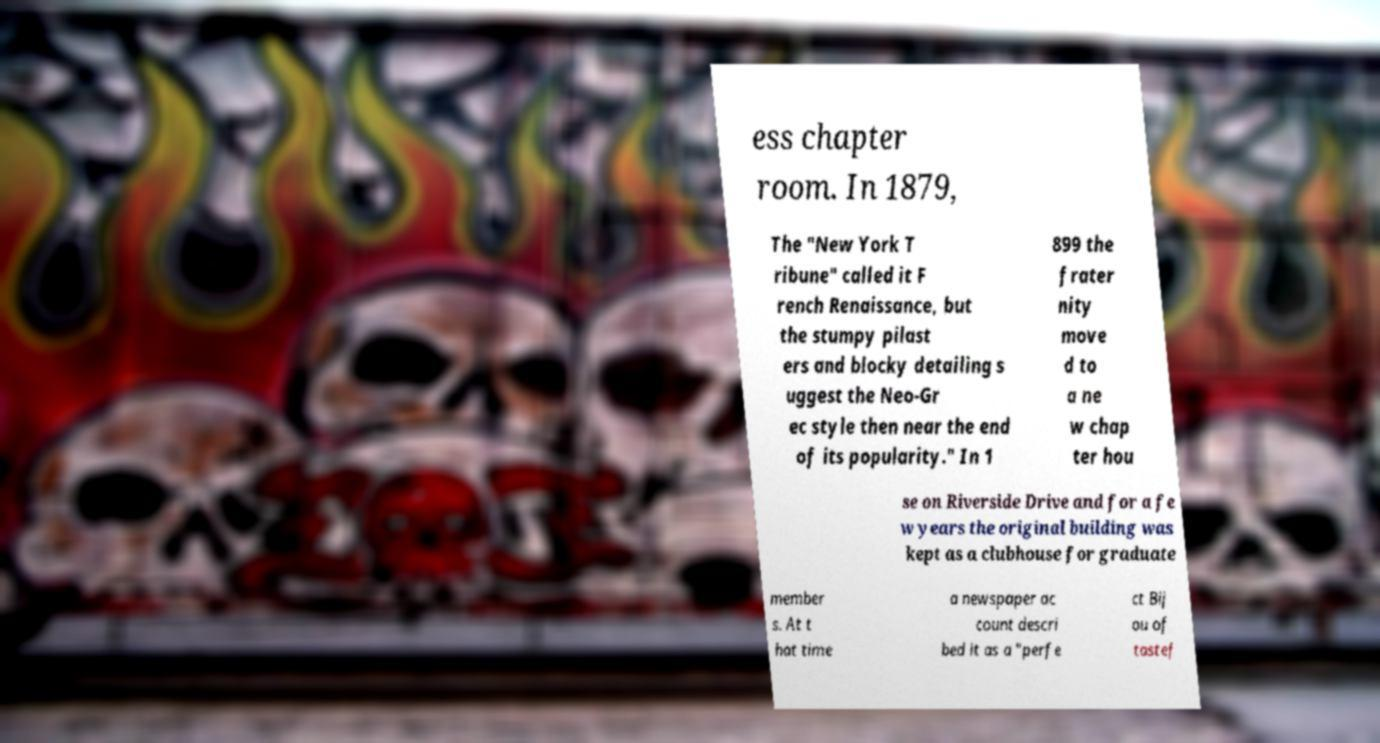Could you extract and type out the text from this image? ess chapter room. In 1879, The "New York T ribune" called it F rench Renaissance, but the stumpy pilast ers and blocky detailing s uggest the Neo-Gr ec style then near the end of its popularity." In 1 899 the frater nity move d to a ne w chap ter hou se on Riverside Drive and for a fe w years the original building was kept as a clubhouse for graduate member s. At t hat time a newspaper ac count descri bed it as a "perfe ct Bij ou of tastef 